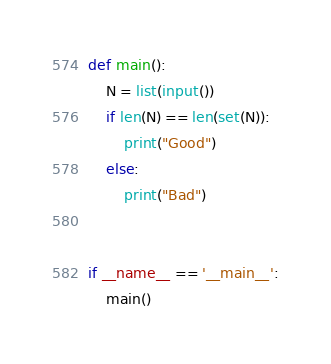Convert code to text. <code><loc_0><loc_0><loc_500><loc_500><_Python_>def main():
    N = list(input())
    if len(N) == len(set(N)):
        print("Good")
    else:
        print("Bad")


if __name__ == '__main__':
    main()
</code> 